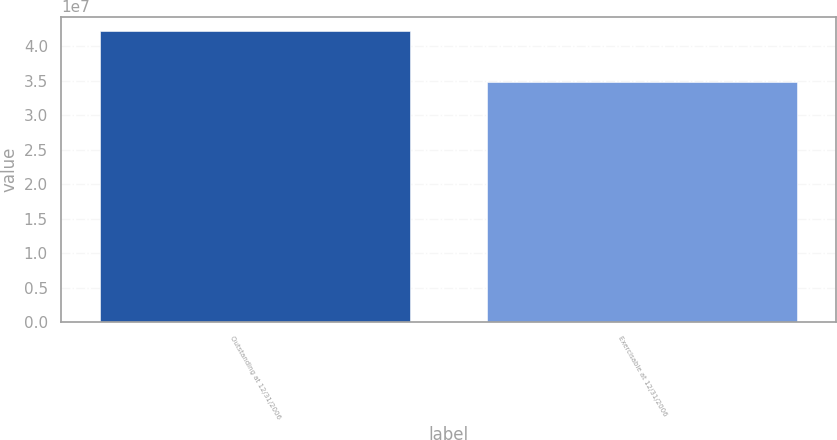Convert chart. <chart><loc_0><loc_0><loc_500><loc_500><bar_chart><fcel>Outstanding at 12/31/2006<fcel>Exercisable at 12/31/2006<nl><fcel>4.22273e+07<fcel>3.48446e+07<nl></chart> 